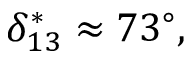<formula> <loc_0><loc_0><loc_500><loc_500>\delta _ { 1 3 } ^ { * } \approx 7 3 ^ { \circ } ,</formula> 